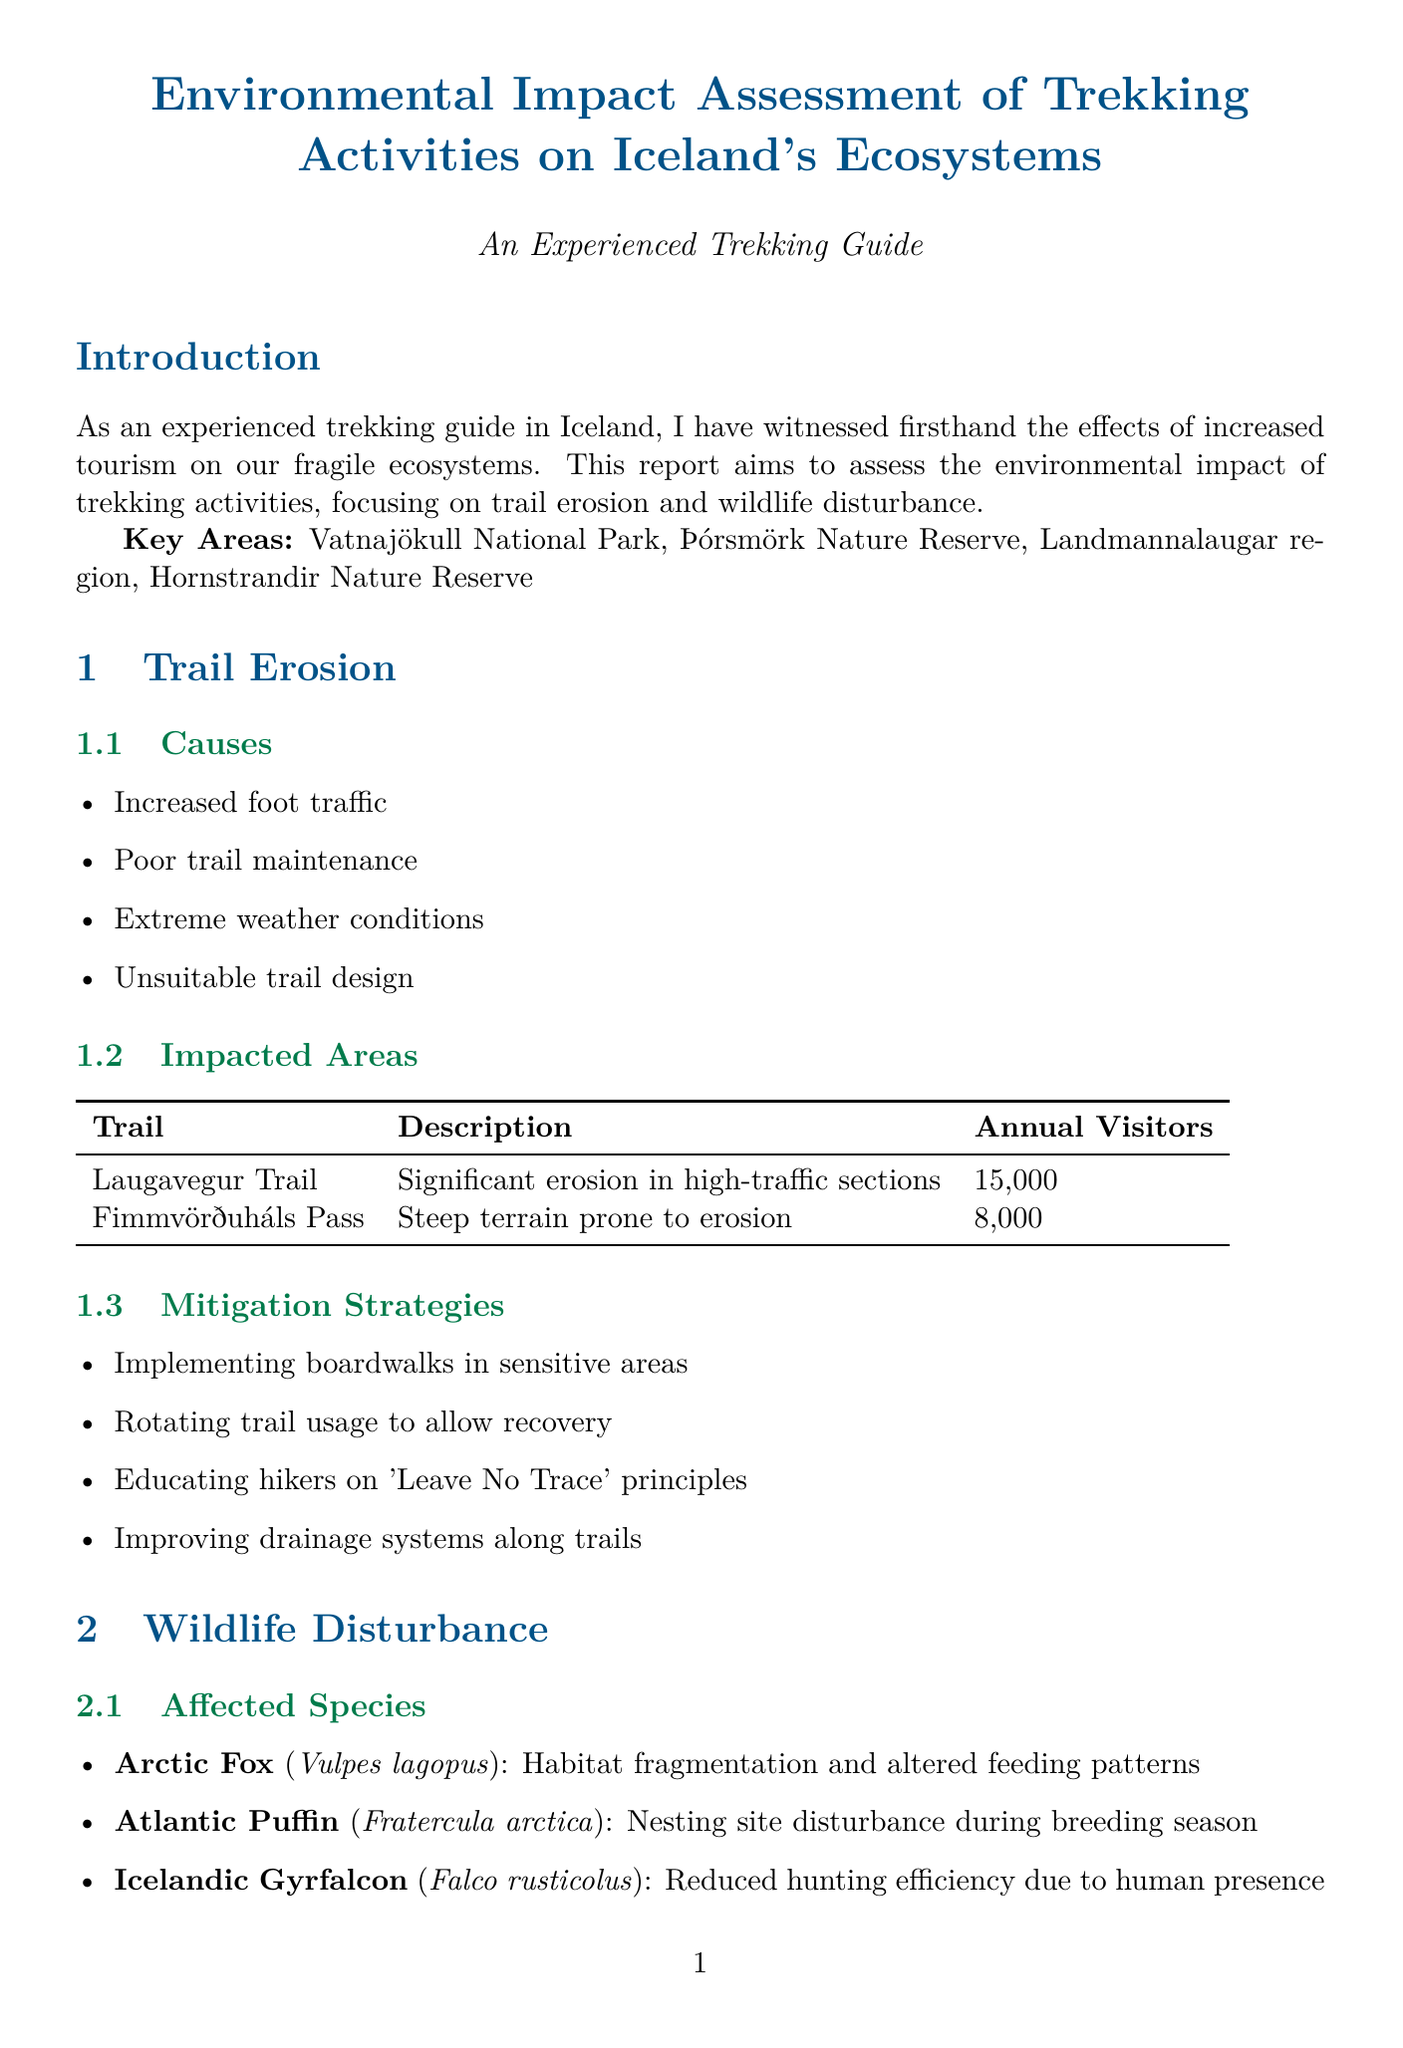What is the title of the report? The title of the report is provided at the beginning of the document.
Answer: Environmental Impact Assessment of Trekking Activities on Iceland's Ecosystems How many annual visitors does the Laugavegur Trail have? The annual visitors for Laugavegur Trail are listed in the impacted areas section of the document.
Answer: 15000 What species is impacted by habitat fragmentation? The affected species section lists species and their impacts.
Answer: Arctic Fox What is one cause of trail erosion mentioned in the report? The report lists several causes of trail erosion in the trail erosion section.
Answer: Increased foot traffic What solution is proposed for glacier retreat in Skaftafell? The case studies section outlines the issues and proposed solutions related to specific locations.
Answer: Rerouting trails and implementing early warning systems How many key areas are mentioned in the introduction? The introduction outlines the key areas of focus in the report.
Answer: Four What is a recommended conservation measure mentioned in the document? The conservation measures section includes various strategies to protect wildlife.
Answer: Establishing wildlife viewing guidelines What impact does trekking have on the Atlantic Puffin? The affected species section specifies the impacts of trekking on different species.
Answer: Nesting site disturbance during breeding season 